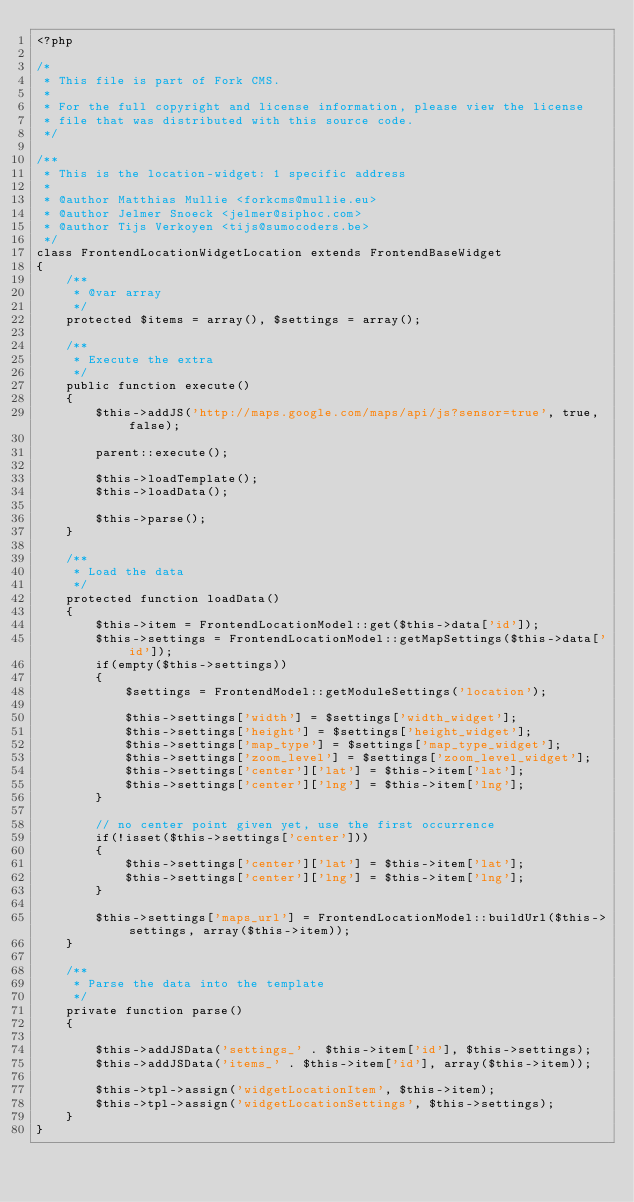Convert code to text. <code><loc_0><loc_0><loc_500><loc_500><_PHP_><?php

/*
 * This file is part of Fork CMS.
 *
 * For the full copyright and license information, please view the license
 * file that was distributed with this source code.
 */

/**
 * This is the location-widget: 1 specific address
 *
 * @author Matthias Mullie <forkcms@mullie.eu>
 * @author Jelmer Snoeck <jelmer@siphoc.com>
 * @author Tijs Verkoyen <tijs@sumocoders.be>
 */
class FrontendLocationWidgetLocation extends FrontendBaseWidget
{
	/**
	 * @var array
	 */
	protected $items = array(), $settings = array();

	/**
	 * Execute the extra
	 */
	public function execute()
	{
		$this->addJS('http://maps.google.com/maps/api/js?sensor=true', true, false);

		parent::execute();

		$this->loadTemplate();
		$this->loadData();

		$this->parse();
	}

	/**
	 * Load the data
	 */
	protected function loadData()
	{
		$this->item = FrontendLocationModel::get($this->data['id']);
		$this->settings = FrontendLocationModel::getMapSettings($this->data['id']);
		if(empty($this->settings))
		{
			$settings = FrontendModel::getModuleSettings('location');

			$this->settings['width'] = $settings['width_widget'];
			$this->settings['height'] = $settings['height_widget'];
			$this->settings['map_type'] = $settings['map_type_widget'];
			$this->settings['zoom_level'] = $settings['zoom_level_widget'];
			$this->settings['center']['lat'] = $this->item['lat'];
			$this->settings['center']['lng'] = $this->item['lng'];
		}

		// no center point given yet, use the first occurrence
		if(!isset($this->settings['center']))
		{
			$this->settings['center']['lat'] = $this->item['lat'];
			$this->settings['center']['lng'] = $this->item['lng'];
		}

		$this->settings['maps_url'] = FrontendLocationModel::buildUrl($this->settings, array($this->item));
	}

	/**
	 * Parse the data into the template
	 */
	private function parse()
	{

		$this->addJSData('settings_' . $this->item['id'], $this->settings);
		$this->addJSData('items_' . $this->item['id'], array($this->item));

		$this->tpl->assign('widgetLocationItem', $this->item);
		$this->tpl->assign('widgetLocationSettings', $this->settings);
	}
}
</code> 